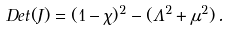<formula> <loc_0><loc_0><loc_500><loc_500>D e t ( J ) = ( 1 - \chi ) ^ { 2 } - ( \Lambda ^ { 2 } + \mu ^ { 2 } ) \, .</formula> 